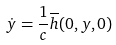<formula> <loc_0><loc_0><loc_500><loc_500>\dot { y } = \frac { 1 } { c } \overline { h } ( 0 , y , 0 )</formula> 